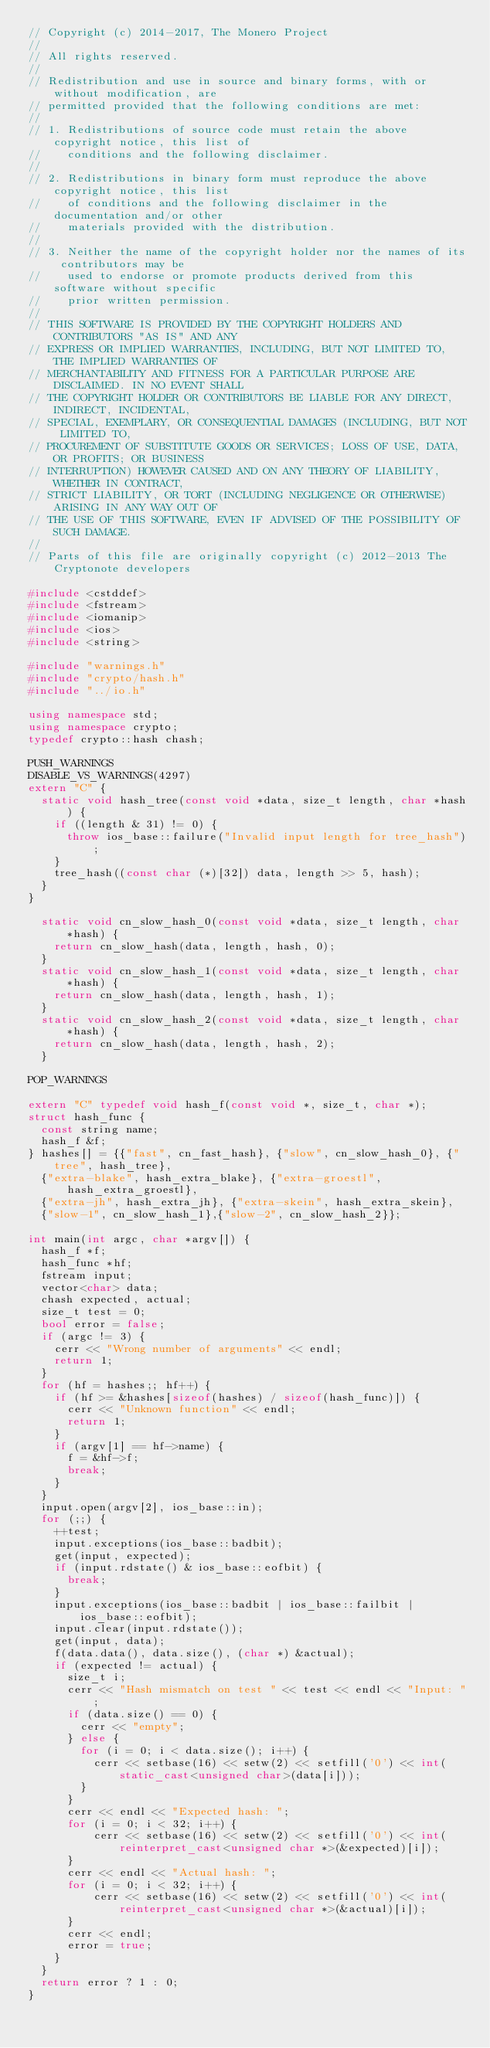<code> <loc_0><loc_0><loc_500><loc_500><_C++_>// Copyright (c) 2014-2017, The Monero Project
// 
// All rights reserved.
// 
// Redistribution and use in source and binary forms, with or without modification, are
// permitted provided that the following conditions are met:
// 
// 1. Redistributions of source code must retain the above copyright notice, this list of
//    conditions and the following disclaimer.
// 
// 2. Redistributions in binary form must reproduce the above copyright notice, this list
//    of conditions and the following disclaimer in the documentation and/or other
//    materials provided with the distribution.
// 
// 3. Neither the name of the copyright holder nor the names of its contributors may be
//    used to endorse or promote products derived from this software without specific
//    prior written permission.
// 
// THIS SOFTWARE IS PROVIDED BY THE COPYRIGHT HOLDERS AND CONTRIBUTORS "AS IS" AND ANY
// EXPRESS OR IMPLIED WARRANTIES, INCLUDING, BUT NOT LIMITED TO, THE IMPLIED WARRANTIES OF
// MERCHANTABILITY AND FITNESS FOR A PARTICULAR PURPOSE ARE DISCLAIMED. IN NO EVENT SHALL
// THE COPYRIGHT HOLDER OR CONTRIBUTORS BE LIABLE FOR ANY DIRECT, INDIRECT, INCIDENTAL,
// SPECIAL, EXEMPLARY, OR CONSEQUENTIAL DAMAGES (INCLUDING, BUT NOT LIMITED TO,
// PROCUREMENT OF SUBSTITUTE GOODS OR SERVICES; LOSS OF USE, DATA, OR PROFITS; OR BUSINESS
// INTERRUPTION) HOWEVER CAUSED AND ON ANY THEORY OF LIABILITY, WHETHER IN CONTRACT,
// STRICT LIABILITY, OR TORT (INCLUDING NEGLIGENCE OR OTHERWISE) ARISING IN ANY WAY OUT OF
// THE USE OF THIS SOFTWARE, EVEN IF ADVISED OF THE POSSIBILITY OF SUCH DAMAGE.
// 
// Parts of this file are originally copyright (c) 2012-2013 The Cryptonote developers

#include <cstddef>
#include <fstream>
#include <iomanip>
#include <ios>
#include <string>

#include "warnings.h"
#include "crypto/hash.h"
#include "../io.h"

using namespace std;
using namespace crypto;
typedef crypto::hash chash;

PUSH_WARNINGS
DISABLE_VS_WARNINGS(4297)
extern "C" {
  static void hash_tree(const void *data, size_t length, char *hash) {
    if ((length & 31) != 0) {
      throw ios_base::failure("Invalid input length for tree_hash");
    }
    tree_hash((const char (*)[32]) data, length >> 5, hash);
  }
}

  static void cn_slow_hash_0(const void *data, size_t length, char *hash) {
    return cn_slow_hash(data, length, hash, 0);
  }
  static void cn_slow_hash_1(const void *data, size_t length, char *hash) {
    return cn_slow_hash(data, length, hash, 1);
  }
  static void cn_slow_hash_2(const void *data, size_t length, char *hash) {
    return cn_slow_hash(data, length, hash, 2);
  }  

POP_WARNINGS

extern "C" typedef void hash_f(const void *, size_t, char *);
struct hash_func {
  const string name;
  hash_f &f;
} hashes[] = {{"fast", cn_fast_hash}, {"slow", cn_slow_hash_0}, {"tree", hash_tree},
  {"extra-blake", hash_extra_blake}, {"extra-groestl", hash_extra_groestl},
  {"extra-jh", hash_extra_jh}, {"extra-skein", hash_extra_skein},
  {"slow-1", cn_slow_hash_1},{"slow-2", cn_slow_hash_2}};

int main(int argc, char *argv[]) {
  hash_f *f;
  hash_func *hf;
  fstream input;
  vector<char> data;
  chash expected, actual;
  size_t test = 0;
  bool error = false;
  if (argc != 3) {
    cerr << "Wrong number of arguments" << endl;
    return 1;
  }
  for (hf = hashes;; hf++) {
    if (hf >= &hashes[sizeof(hashes) / sizeof(hash_func)]) {
      cerr << "Unknown function" << endl;
      return 1;
    }
    if (argv[1] == hf->name) {
      f = &hf->f;
      break;
    }
  }
  input.open(argv[2], ios_base::in);
  for (;;) {
    ++test;
    input.exceptions(ios_base::badbit);
    get(input, expected);
    if (input.rdstate() & ios_base::eofbit) {
      break;
    }
    input.exceptions(ios_base::badbit | ios_base::failbit | ios_base::eofbit);
    input.clear(input.rdstate());
    get(input, data);
    f(data.data(), data.size(), (char *) &actual);
    if (expected != actual) {
      size_t i;
      cerr << "Hash mismatch on test " << test << endl << "Input: ";
      if (data.size() == 0) {
        cerr << "empty";
      } else {
        for (i = 0; i < data.size(); i++) {
          cerr << setbase(16) << setw(2) << setfill('0') << int(static_cast<unsigned char>(data[i]));
        }
      }
      cerr << endl << "Expected hash: ";
      for (i = 0; i < 32; i++) {
          cerr << setbase(16) << setw(2) << setfill('0') << int(reinterpret_cast<unsigned char *>(&expected)[i]);
      }
      cerr << endl << "Actual hash: ";
      for (i = 0; i < 32; i++) {
          cerr << setbase(16) << setw(2) << setfill('0') << int(reinterpret_cast<unsigned char *>(&actual)[i]);
      }
      cerr << endl;
      error = true;
    }
  }
  return error ? 1 : 0;
}
</code> 